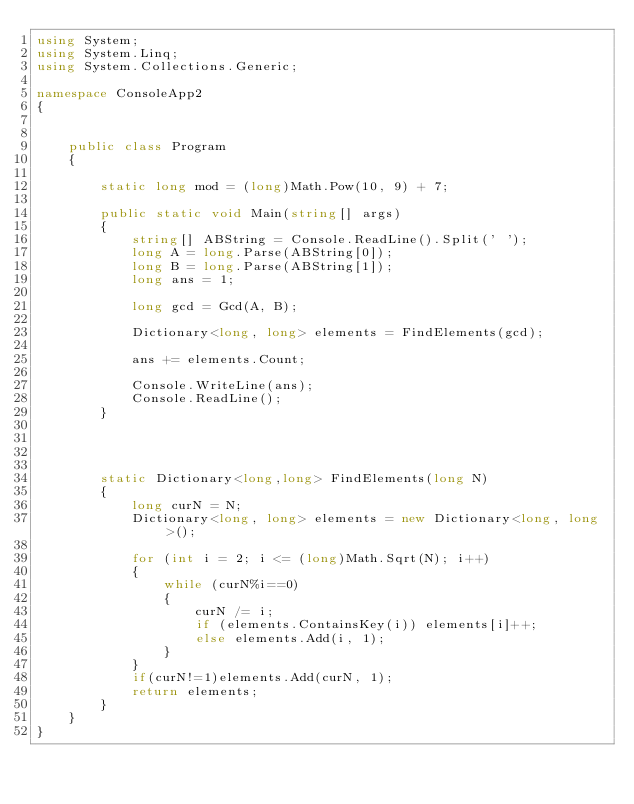Convert code to text. <code><loc_0><loc_0><loc_500><loc_500><_C#_>using System;
using System.Linq;
using System.Collections.Generic;

namespace ConsoleApp2
{


    public class Program
    {

        static long mod = (long)Math.Pow(10, 9) + 7;

        public static void Main(string[] args)
        {
            string[] ABString = Console.ReadLine().Split(' ');
            long A = long.Parse(ABString[0]);
            long B = long.Parse(ABString[1]);
            long ans = 1;

            long gcd = Gcd(A, B);

            Dictionary<long, long> elements = FindElements(gcd);

            ans += elements.Count;
            
            Console.WriteLine(ans);
            Console.ReadLine();
        }




        static Dictionary<long,long> FindElements(long N)
        {
            long curN = N;
            Dictionary<long, long> elements = new Dictionary<long, long>();
           
            for (int i = 2; i <= (long)Math.Sqrt(N); i++)
            {
                while (curN%i==0)
                {
                    curN /= i;
                    if (elements.ContainsKey(i)) elements[i]++;
                    else elements.Add(i, 1);
                }
            }
            if(curN!=1)elements.Add(curN, 1);
            return elements;
        }
    }
}
</code> 